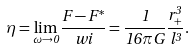Convert formula to latex. <formula><loc_0><loc_0><loc_500><loc_500>\eta = \lim _ { \omega \rightarrow 0 } \frac { F - F ^ { * } } { w i } = \frac { 1 } { 1 6 \pi G } \frac { r _ { + } ^ { 3 } } { l ^ { 3 } } .</formula> 